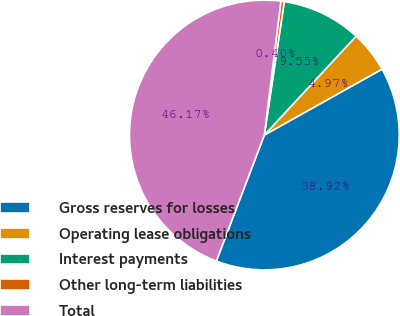Convert chart to OTSL. <chart><loc_0><loc_0><loc_500><loc_500><pie_chart><fcel>Gross reserves for losses<fcel>Operating lease obligations<fcel>Interest payments<fcel>Other long-term liabilities<fcel>Total<nl><fcel>38.92%<fcel>4.97%<fcel>9.55%<fcel>0.4%<fcel>46.17%<nl></chart> 